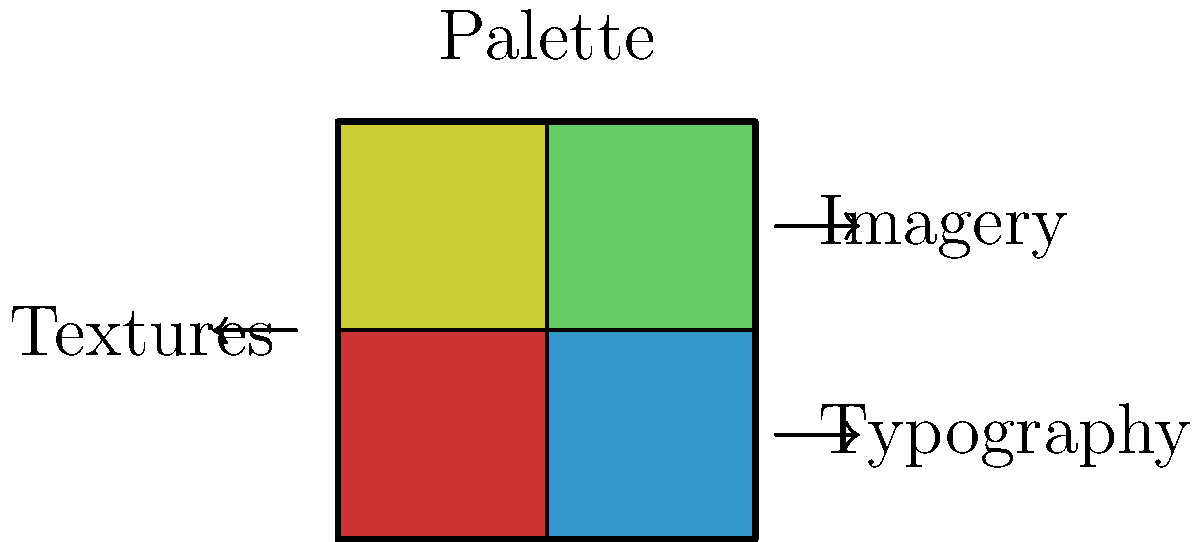As a film director planning a psychological thriller set in a dystopian future, you want to create a mood board to convey the atmosphere and style of your project. Which element in the mood board diagram would be most crucial for establishing the visual tone and color scheme of your film? To answer this question, let's consider the elements of a mood board and their importance in establishing the visual tone and color scheme for a psychological thriller set in a dystopian future:

1. Palette: This element is crucial for setting the overall color scheme of the film. In a dystopian future setting, you might use muted, desaturated colors or high-contrast combinations to create a sense of unease and alienation.

2. Imagery: While important for providing specific visual references, imagery alone doesn't establish the overall color scheme and tone as effectively as the palette.

3. Typography: Typography is essential for titles and credits, but it doesn't play a primary role in establishing the visual tone and color scheme of the entire film.

4. Textures: Textures can add depth and richness to the visual style, but they are secondary to the color palette in establishing the overall tone.

For a psychological thriller in a dystopian setting, the color palette is the most crucial element for establishing the visual tone and color scheme. It will inform all other visual aspects of the film, including set design, costume choices, and lighting. The palette can create a consistent atmosphere of tension, unease, or alienation that permeates every frame of the film.

Therefore, the palette element of the mood board would be the most crucial for establishing the visual tone and color scheme of your psychological thriller set in a dystopian future.
Answer: Palette 